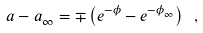<formula> <loc_0><loc_0><loc_500><loc_500>a - a _ { \infty } = \mp \left ( e ^ { - \phi } - e ^ { - \phi _ { \infty } } \right ) \ ,</formula> 